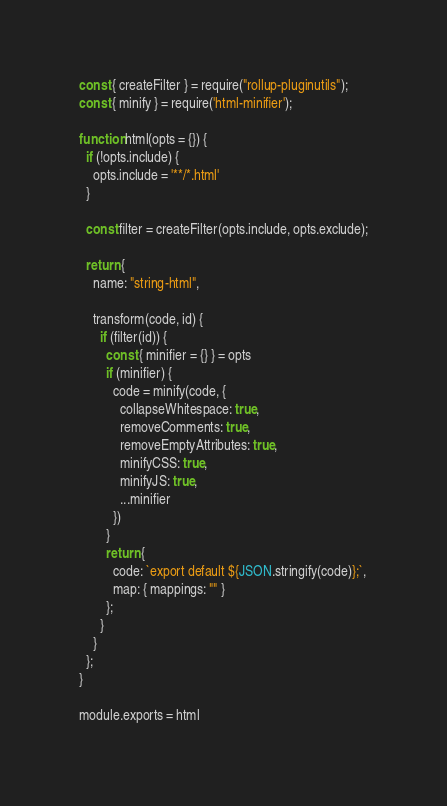Convert code to text. <code><loc_0><loc_0><loc_500><loc_500><_JavaScript_>const { createFilter } = require("rollup-pluginutils");
const { minify } = require('html-minifier');

function html(opts = {}) {
  if (!opts.include) {
    opts.include = '**/*.html'
  }

  const filter = createFilter(opts.include, opts.exclude);

  return {
    name: "string-html",

    transform(code, id) {
      if (filter(id)) {
        const { minifier = {} } = opts
        if (minifier) {
          code = minify(code, {
            collapseWhitespace: true,
            removeComments: true,
            removeEmptyAttributes: true,
            minifyCSS: true,
            minifyJS: true,
            ...minifier
          })
        }
        return {
          code: `export default ${JSON.stringify(code)};`,
          map: { mappings: "" }
        };
      }
    }
  };
}

module.exports = html
</code> 